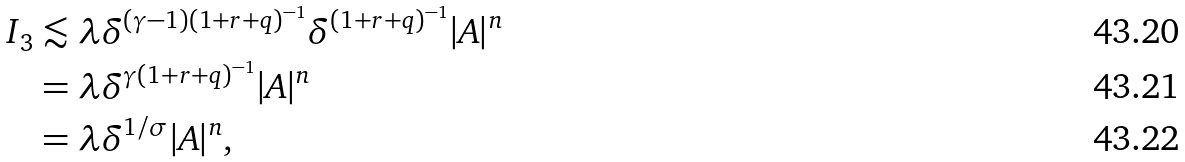Convert formula to latex. <formula><loc_0><loc_0><loc_500><loc_500>I _ { 3 } & \lesssim \lambda \delta ^ { ( \gamma - 1 ) ( 1 + r + q ) ^ { - 1 } } \delta ^ { ( 1 + r + q ) ^ { - 1 } } | A | ^ { n } \\ & = \lambda \delta ^ { \gamma ( 1 + r + q ) ^ { - 1 } } | A | ^ { n } \\ & = \lambda \delta ^ { 1 / \sigma } | A | ^ { n } ,</formula> 